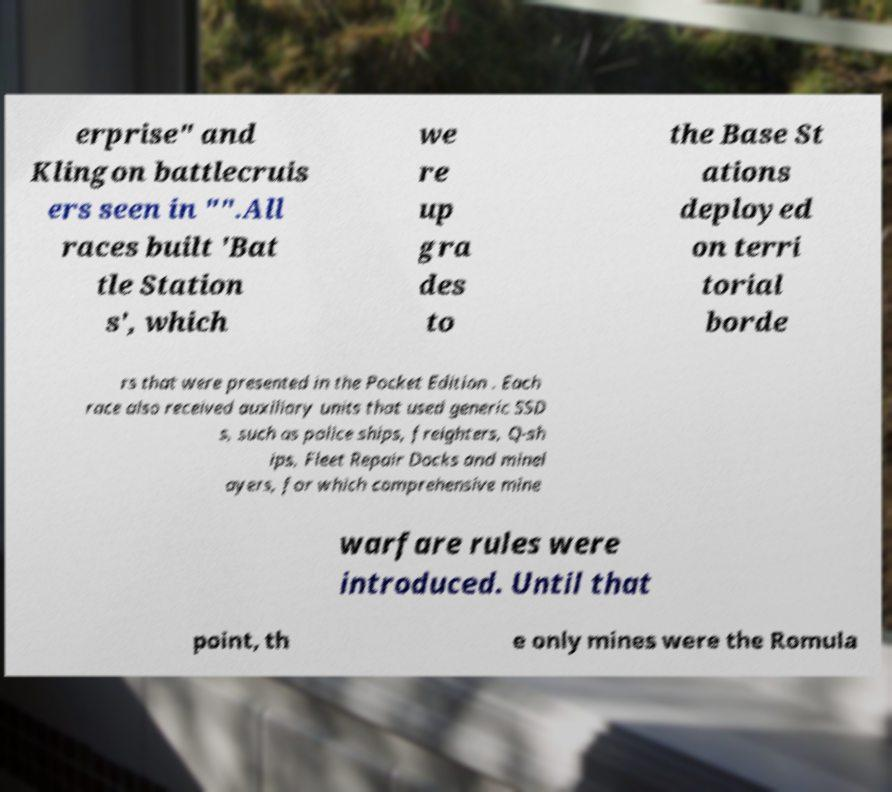For documentation purposes, I need the text within this image transcribed. Could you provide that? erprise" and Klingon battlecruis ers seen in "".All races built 'Bat tle Station s', which we re up gra des to the Base St ations deployed on terri torial borde rs that were presented in the Pocket Edition . Each race also received auxiliary units that used generic SSD s, such as police ships, freighters, Q-sh ips, Fleet Repair Docks and minel ayers, for which comprehensive mine warfare rules were introduced. Until that point, th e only mines were the Romula 